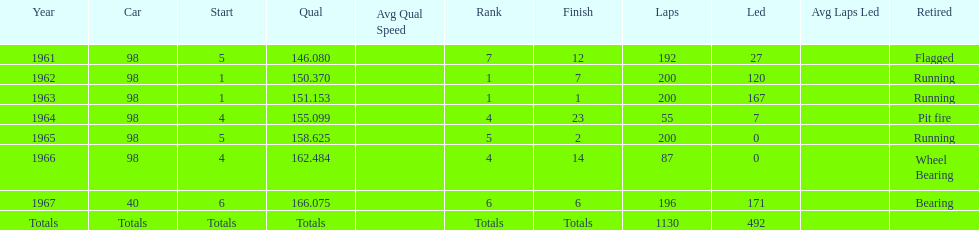What is the difference between the qualfying time in 1967 and 1965? 7.45. 